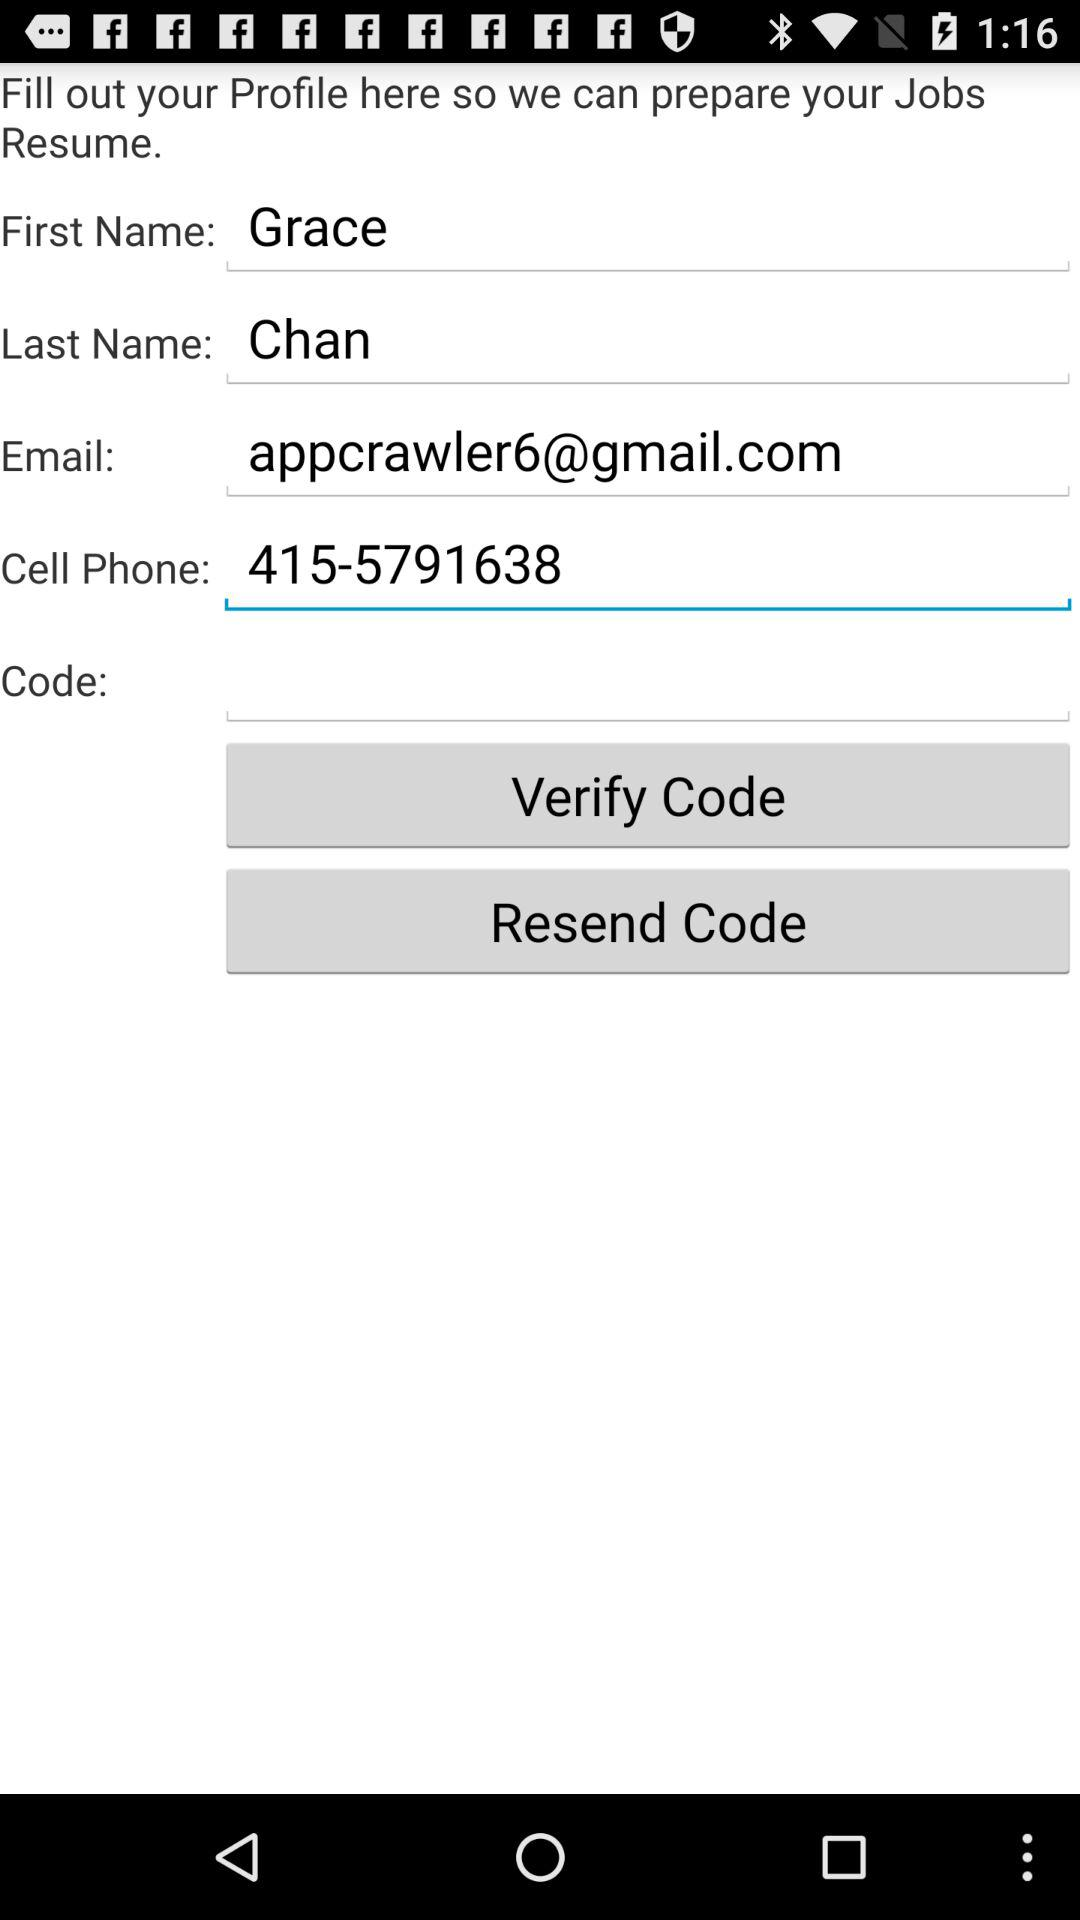What's the last name? The last name is Chan. 